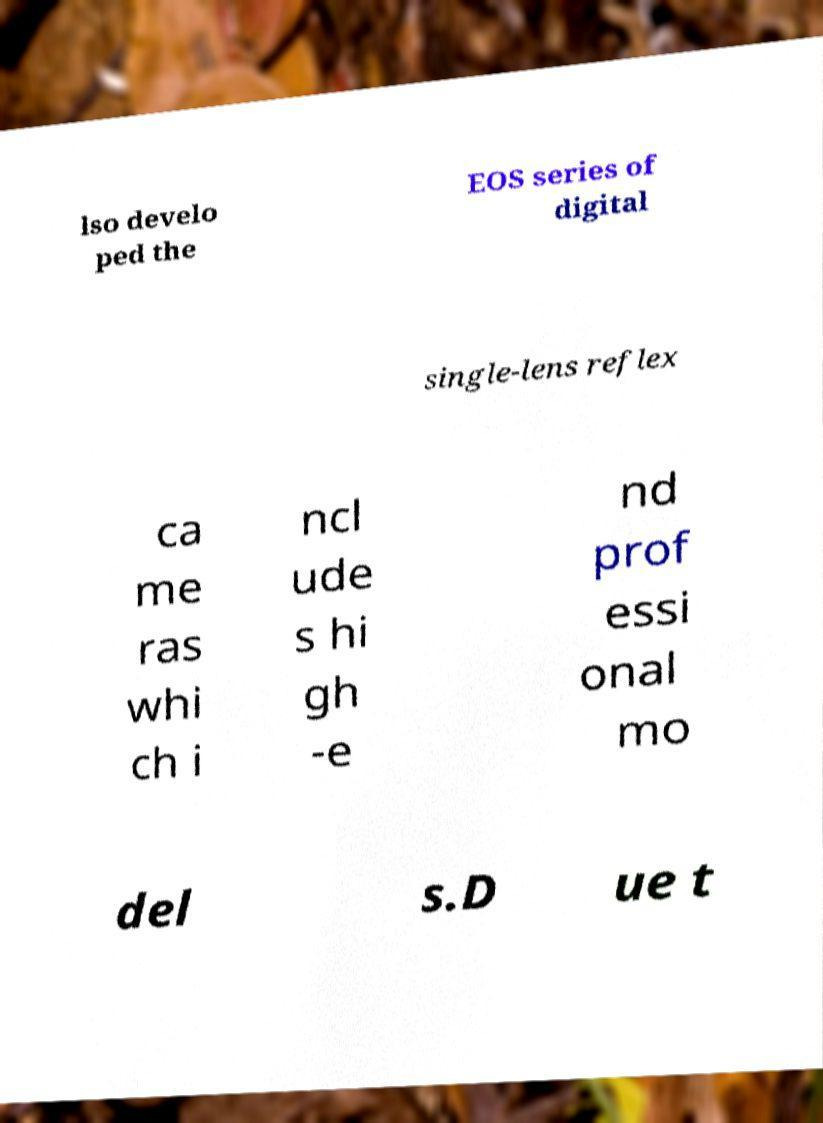For documentation purposes, I need the text within this image transcribed. Could you provide that? lso develo ped the EOS series of digital single-lens reflex ca me ras whi ch i ncl ude s hi gh -e nd prof essi onal mo del s.D ue t 